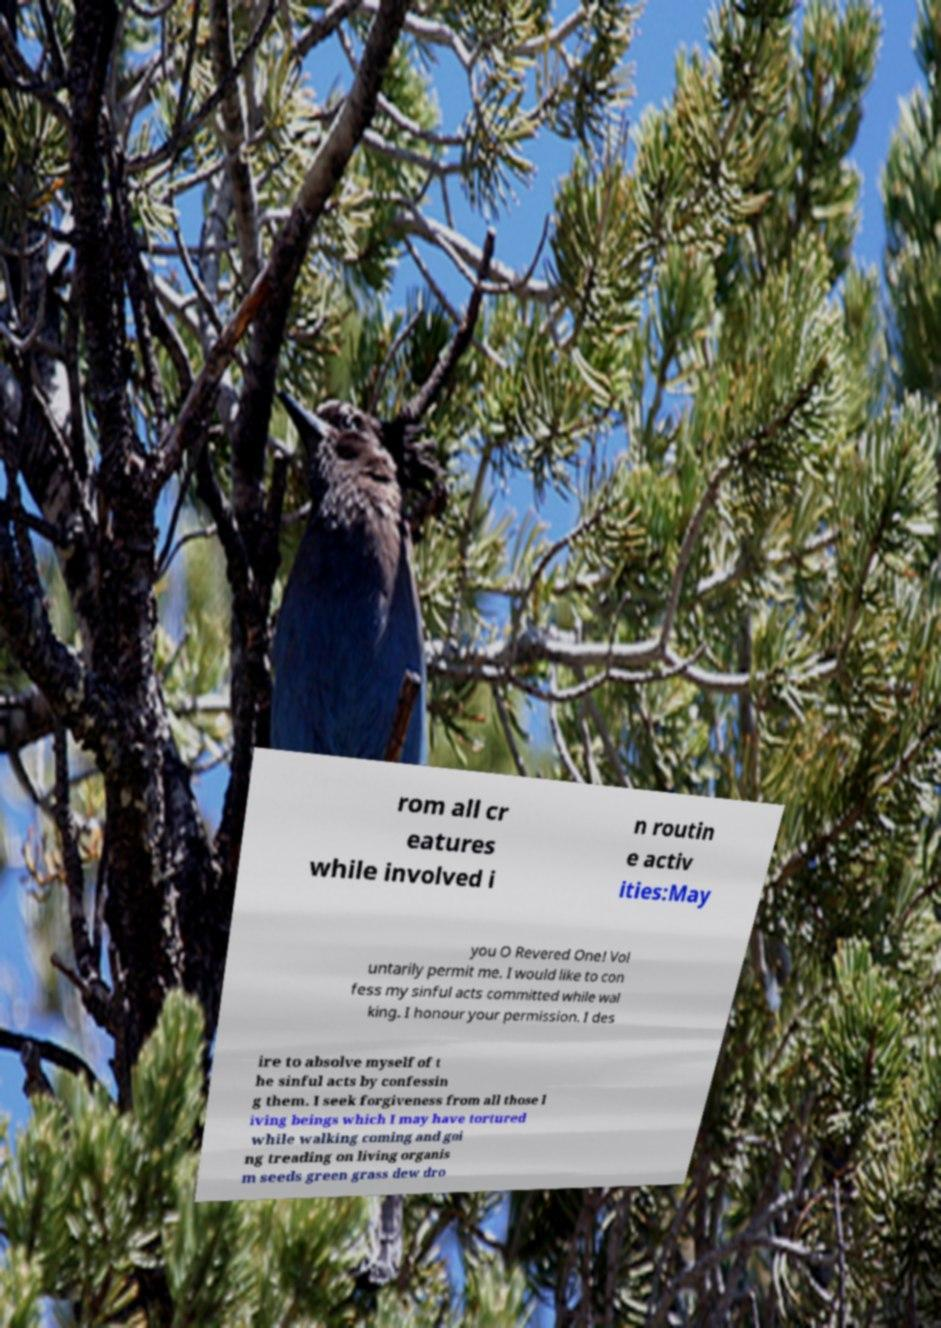Please identify and transcribe the text found in this image. rom all cr eatures while involved i n routin e activ ities:May you O Revered One! Vol untarily permit me. I would like to con fess my sinful acts committed while wal king. I honour your permission. I des ire to absolve myself of t he sinful acts by confessin g them. I seek forgiveness from all those l iving beings which I may have tortured while walking coming and goi ng treading on living organis m seeds green grass dew dro 